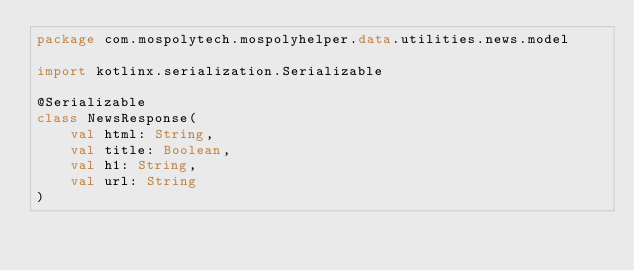<code> <loc_0><loc_0><loc_500><loc_500><_Kotlin_>package com.mospolytech.mospolyhelper.data.utilities.news.model

import kotlinx.serialization.Serializable

@Serializable
class NewsResponse(
    val html: String,
    val title: Boolean,
    val h1: String,
    val url: String
)</code> 